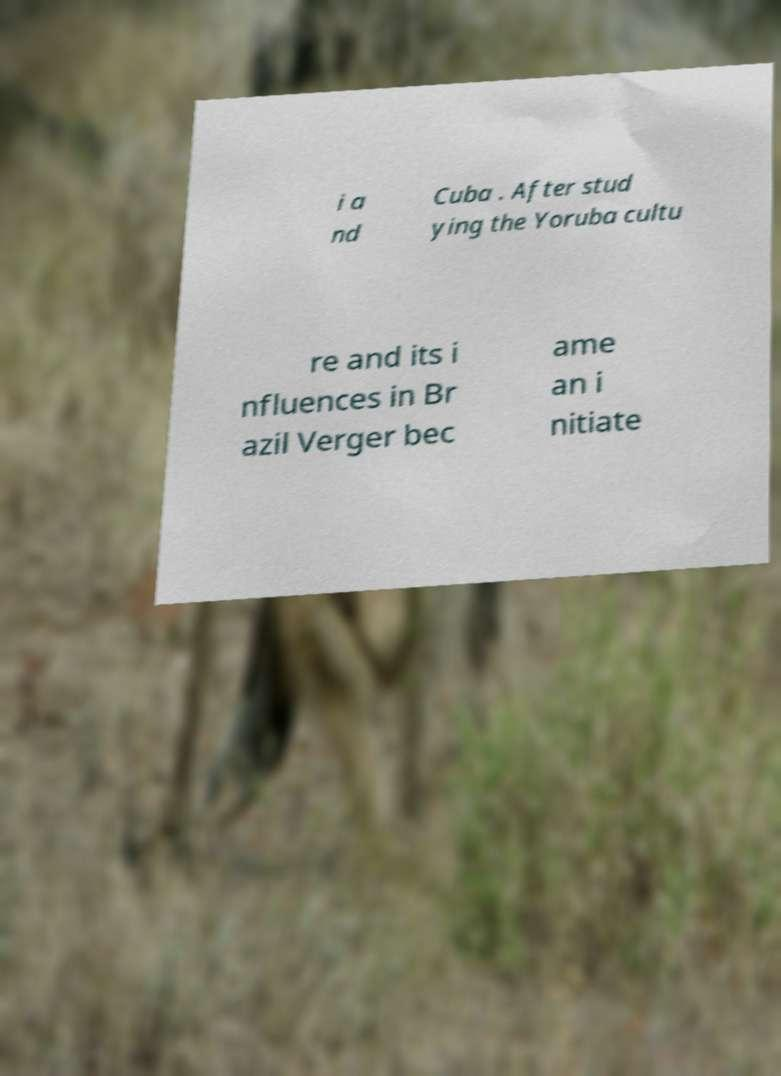What messages or text are displayed in this image? I need them in a readable, typed format. i a nd Cuba . After stud ying the Yoruba cultu re and its i nfluences in Br azil Verger bec ame an i nitiate 